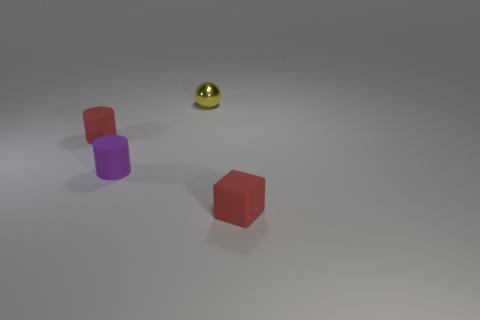How many objects are there in total, and can you tell if any of them are identical? In the image, there are three objects in total: a red cylinder, a purple cylinder, and a golden sphere. None of the objects are identical; they have differences in color and shape. 